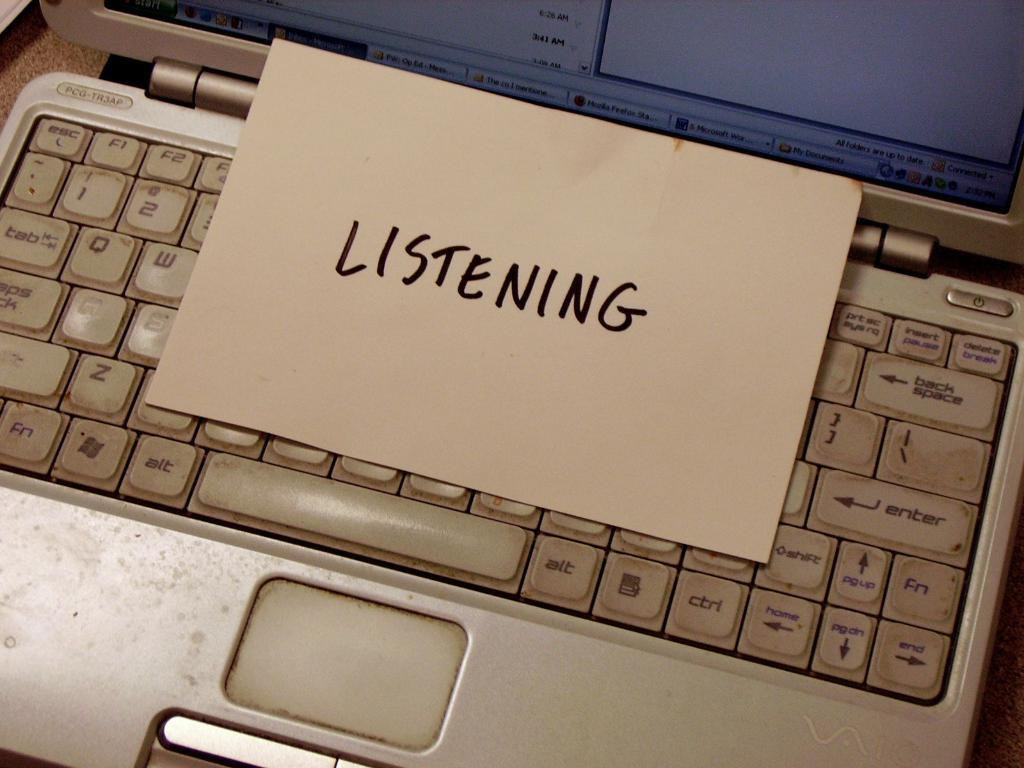Provide a one-sentence caption for the provided image. A note that reads Listening is left on a dirty keyboard. 